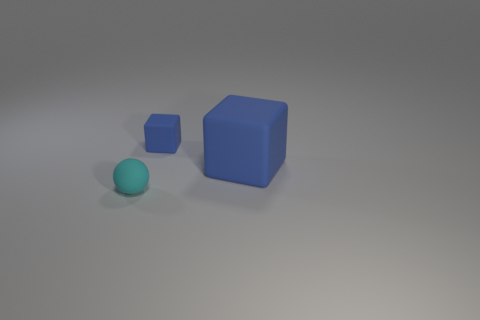Are there any large rubber objects on the left side of the blue object right of the tiny thing that is on the right side of the cyan rubber sphere?
Give a very brief answer. No. There is another rubber cube that is the same color as the small block; what size is it?
Give a very brief answer. Large. Are there any blue things to the right of the tiny rubber cube?
Keep it short and to the point. Yes. How many other things are there of the same shape as the tiny cyan object?
Ensure brevity in your answer.  0. What is the color of the matte block that is the same size as the sphere?
Ensure brevity in your answer.  Blue. Is the number of big objects to the right of the big blue cube less than the number of rubber things in front of the small matte cube?
Your answer should be very brief. Yes. What number of blocks are on the left side of the blue matte block in front of the tiny object that is on the right side of the matte sphere?
Keep it short and to the point. 1. There is another blue object that is the same shape as the big blue thing; what size is it?
Your response must be concise. Small. Is there any other thing that has the same size as the rubber ball?
Make the answer very short. Yes. Are there fewer small cyan things that are behind the large blue rubber thing than blue shiny cylinders?
Provide a short and direct response. No. 